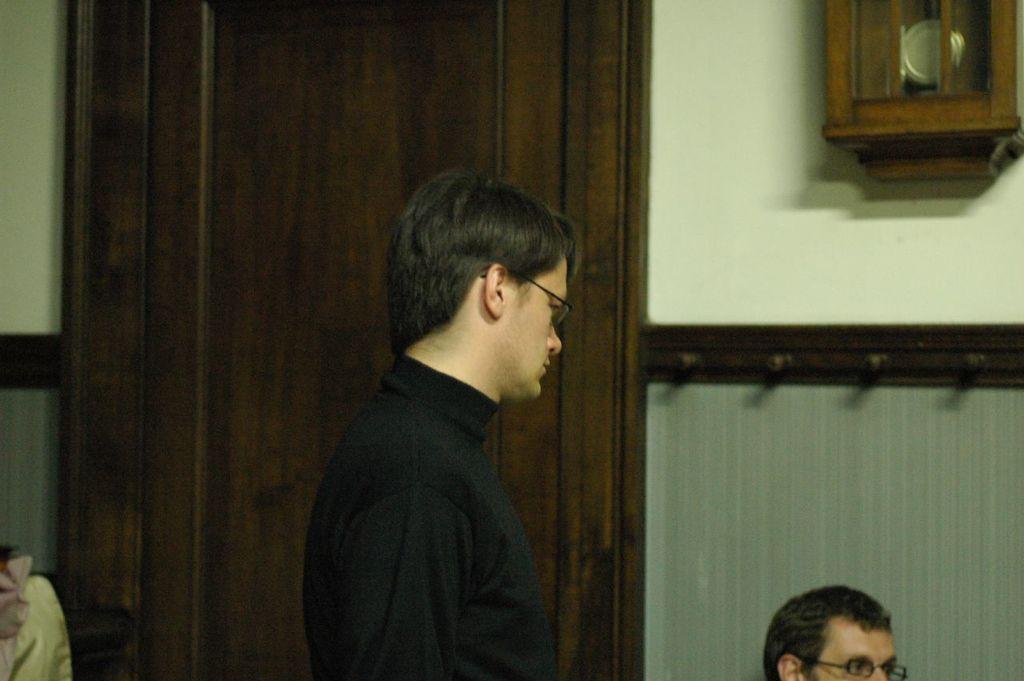Could you give a brief overview of what you see in this image? In the center of the image we can see a person with black t shirt. Image also consists of another person. There is a wall clock in this image. We can also see a door. 